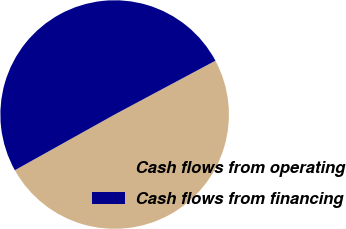Convert chart to OTSL. <chart><loc_0><loc_0><loc_500><loc_500><pie_chart><fcel>Cash flows from operating<fcel>Cash flows from financing<nl><fcel>49.71%<fcel>50.29%<nl></chart> 